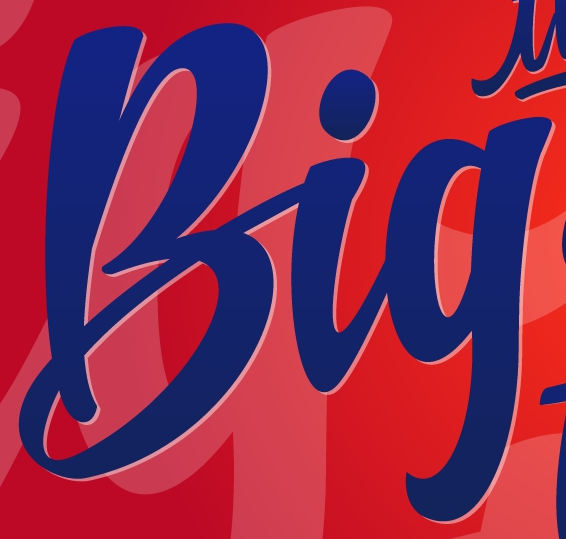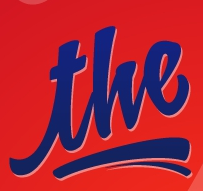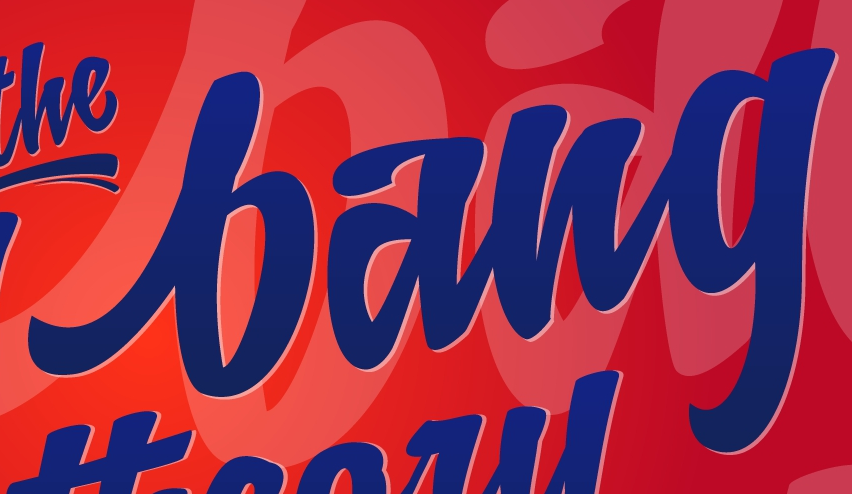What text is displayed in these images sequentially, separated by a semicolon? Big; the; bang 